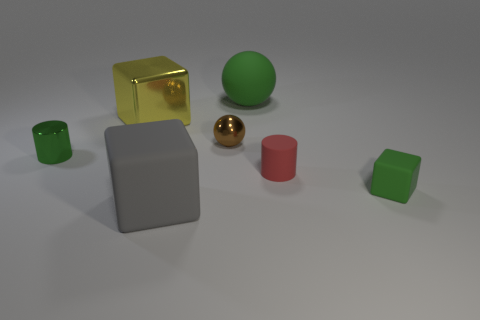Subtract all tiny rubber blocks. How many blocks are left? 2 Subtract all yellow blocks. How many blocks are left? 2 Subtract all blocks. How many objects are left? 4 Add 2 cyan metal cylinders. How many cyan metal cylinders exist? 2 Add 2 small red rubber cylinders. How many objects exist? 9 Subtract 1 green cubes. How many objects are left? 6 Subtract 3 blocks. How many blocks are left? 0 Subtract all green spheres. Subtract all yellow blocks. How many spheres are left? 1 Subtract all brown cylinders. How many green blocks are left? 1 Subtract all large purple cylinders. Subtract all green blocks. How many objects are left? 6 